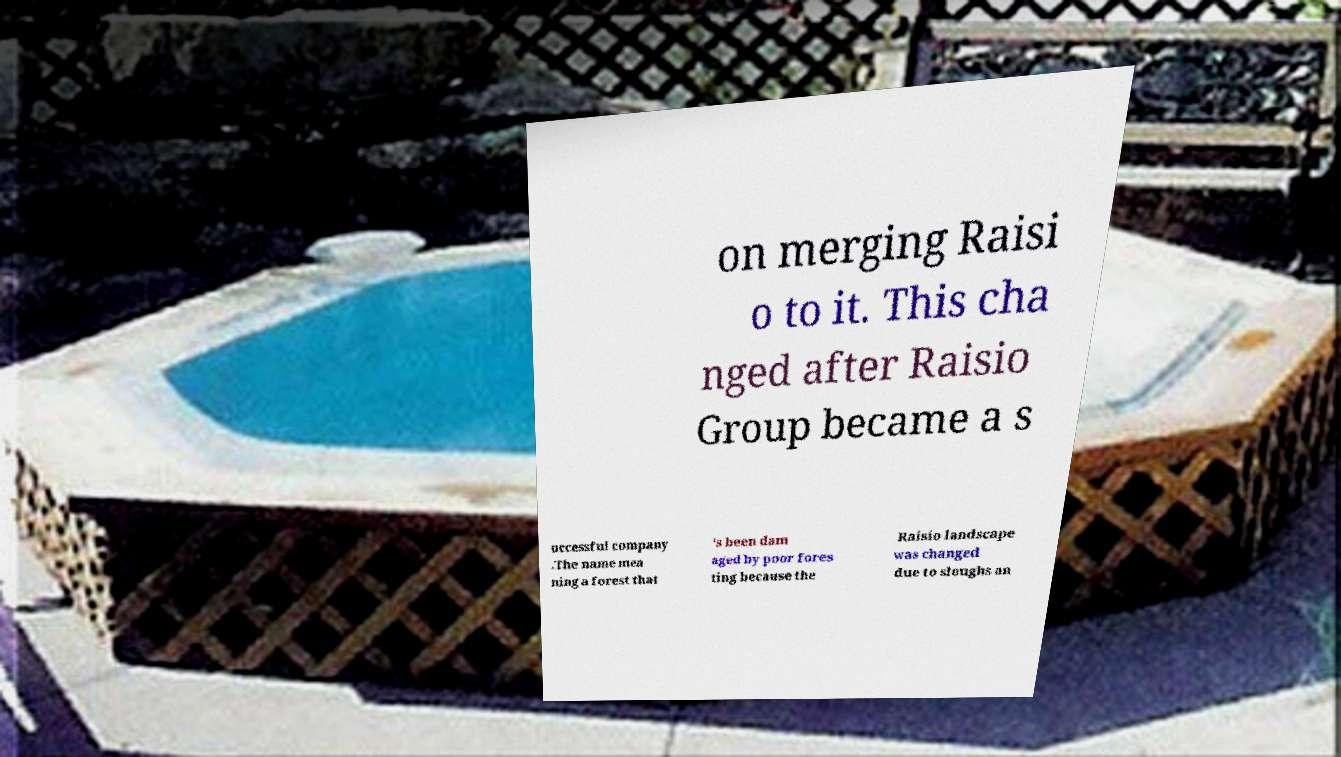Could you extract and type out the text from this image? on merging Raisi o to it. This cha nged after Raisio Group became a s uccessful company .The name mea ning a forest that 's been dam aged by poor fores ting because the Raisio landscape was changed due to sloughs an 